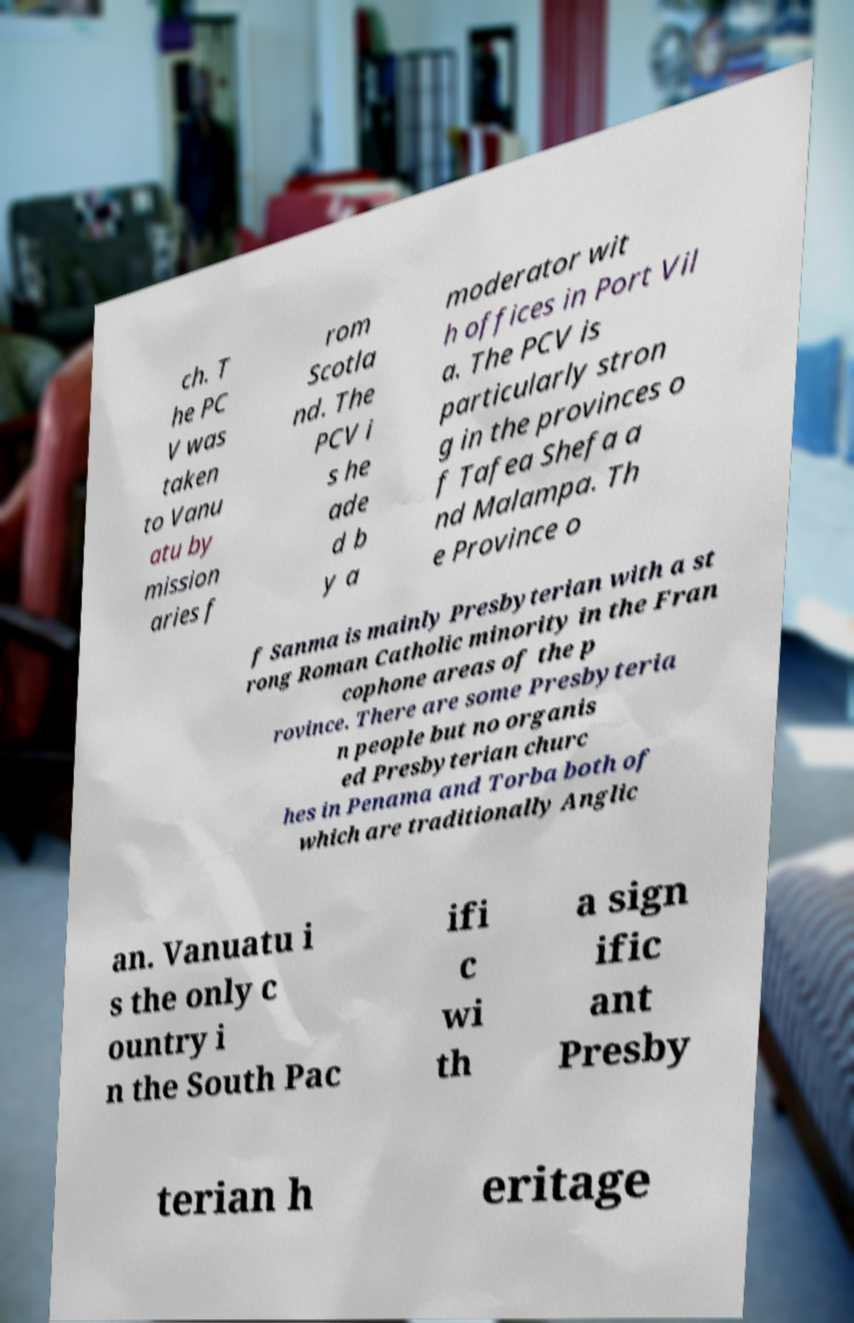Please read and relay the text visible in this image. What does it say? ch. T he PC V was taken to Vanu atu by mission aries f rom Scotla nd. The PCV i s he ade d b y a moderator wit h offices in Port Vil a. The PCV is particularly stron g in the provinces o f Tafea Shefa a nd Malampa. Th e Province o f Sanma is mainly Presbyterian with a st rong Roman Catholic minority in the Fran cophone areas of the p rovince. There are some Presbyteria n people but no organis ed Presbyterian churc hes in Penama and Torba both of which are traditionally Anglic an. Vanuatu i s the only c ountry i n the South Pac ifi c wi th a sign ific ant Presby terian h eritage 